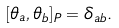Convert formula to latex. <formula><loc_0><loc_0><loc_500><loc_500>[ \theta _ { a } , \theta _ { b } ] _ { P } = \delta _ { a b } .</formula> 